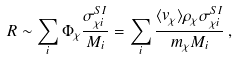<formula> <loc_0><loc_0><loc_500><loc_500>R \sim \sum _ { i } \Phi _ { \chi } \frac { \sigma ^ { S I } _ { \chi i } } { M _ { i } } = \sum _ { i } \frac { \langle v _ { \chi } \rangle \rho _ { \chi } \sigma ^ { S I } _ { \chi i } } { m _ { \chi } M _ { i } } \, ,</formula> 